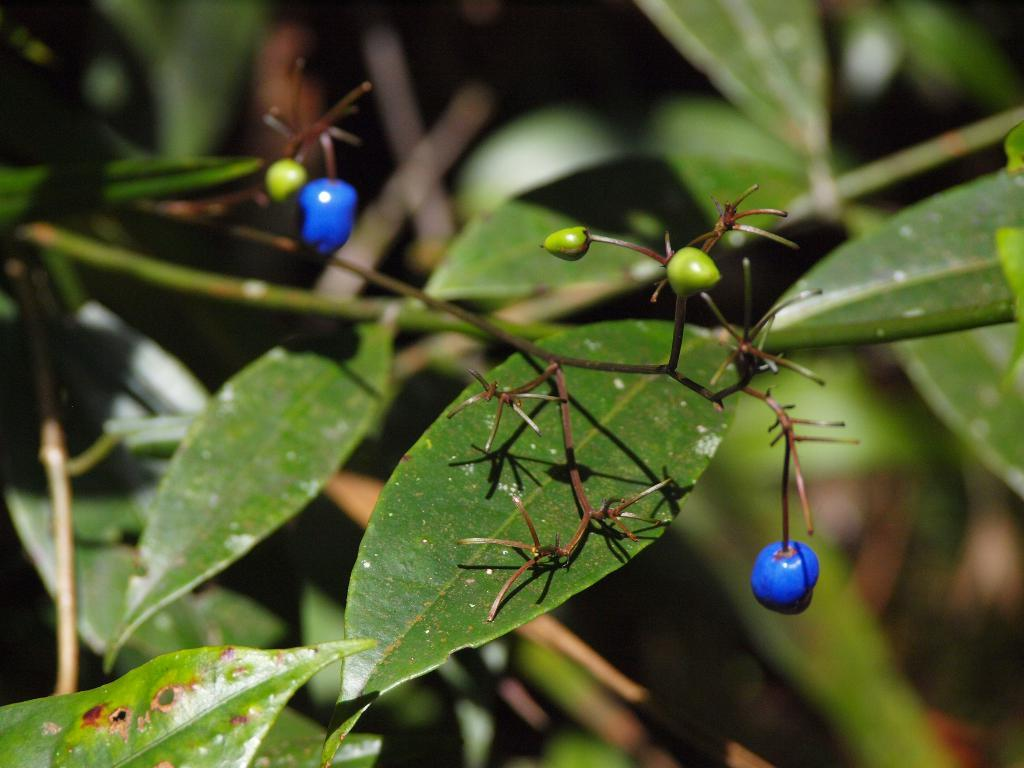What type of small fruits can be seen in the image? There are small fruits in the image. What else is present in the image besides the fruits? There are leaves and stems in the image. What emotion is the fruit feeling in the image? Fruits do not have emotions, so it is not possible to determine the emotion of the fruit in the image. 